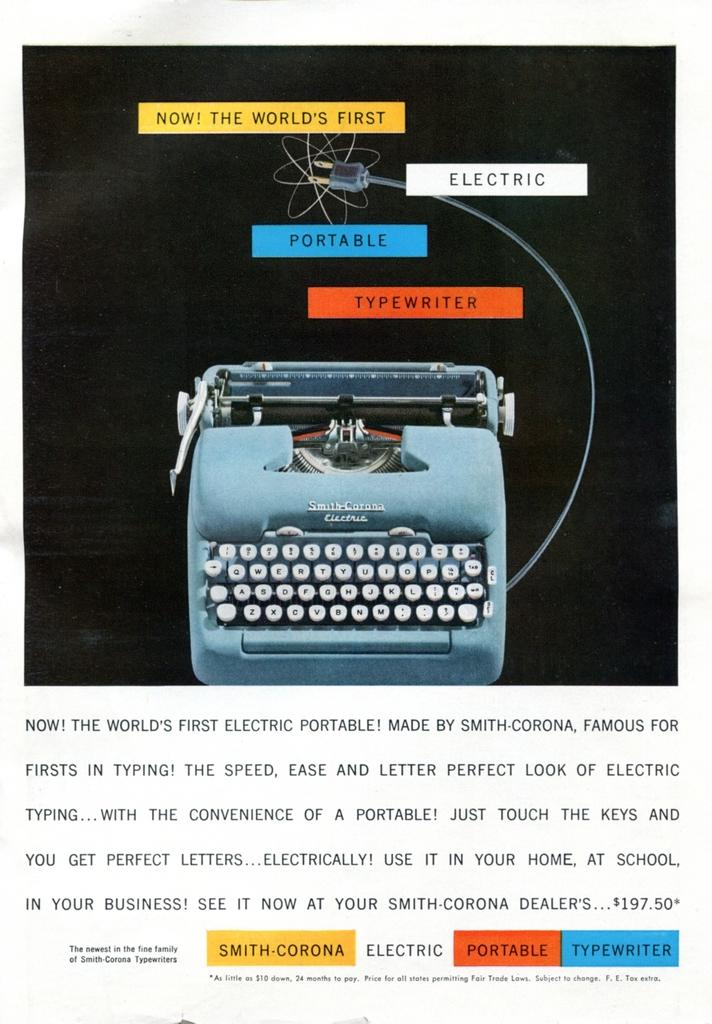<image>
Give a short and clear explanation of the subsequent image. a typewriter that has the word portable above it 